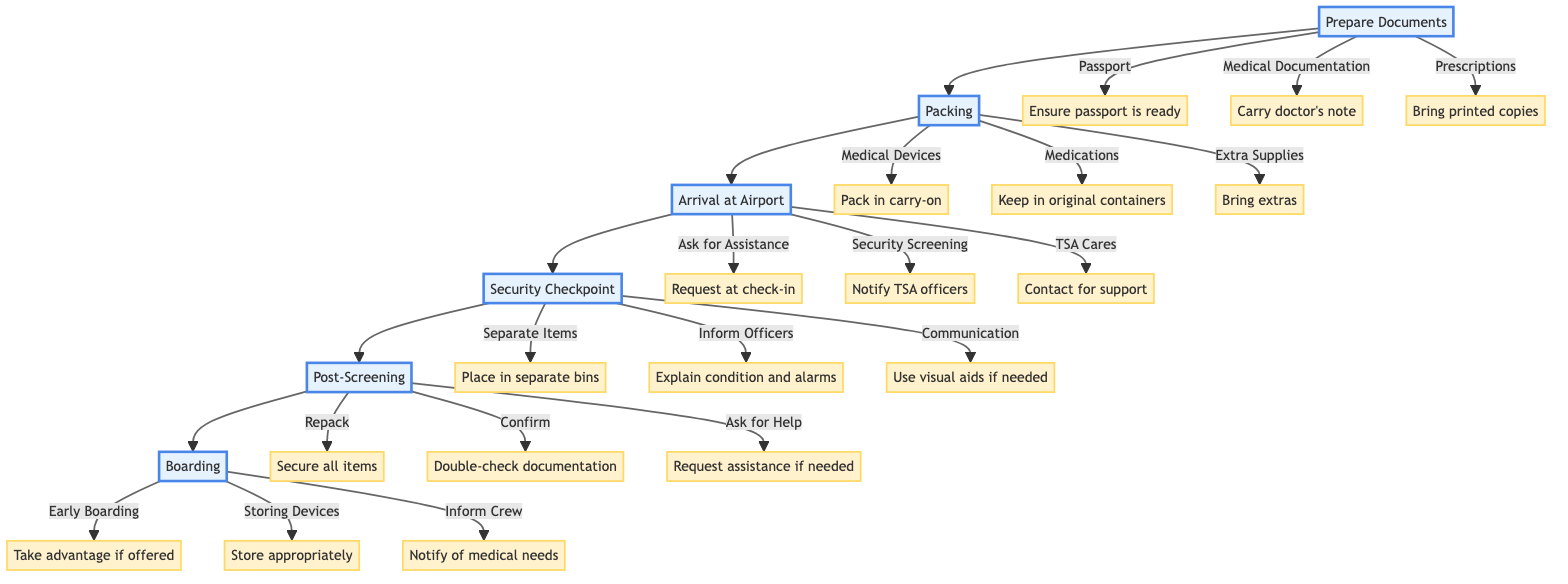What is the first step in the diagram? The diagram starts with the first step labeled "Prepare Documents". Therefore, the first step refers to gathering necessary documents prior to arriving at the airport.
Answer: Prepare Documents How many steps are there in the entire process? By counting the distinct steps, there are a total of six steps outlined in the diagram. These steps are: Prepare Documents, Packing, Arrival at Airport, Security Checkpoint, Post-Screening, and Boarding.
Answer: 6 What is included in the "Packing" step? The "Packing" step includes three key details: Pack medical devices in your carry-on bag, Keep medications in their original, labeled containers, and Bring extra batteries and supplies for your medical devices.
Answer: Medical Devices, Medications, Extra Supplies Which step comes after "Security Checkpoint"? The step that follows "Security Checkpoint" is "Post-Screening". This means after completing the security check, the next part of the process is to repack and confirm the medical items.
Answer: Post-Screening What should you do upon arrival at the airport if you need assistance? If assistance is needed when you arrive at the airport, you should request help at the check-in counter. This indicates the importance of seeking support for easier navigation through the airport.
Answer: Ask for Assistance What are two key actions to take during the "Security Checkpoint"? During the "Security Checkpoint," two important actions are to place medical devices and medications in separate bins and to clearly explain your medical condition and any device alarms to TSA officers. These actions ensure proper handling during security screening.
Answer: Separate Medical Items, Inform TSA Officers What is a suggested practice for boarding? One suggested practice for boarding is to take advantage of early boarding options. This allows individuals to have more time to settle in after boarding the aircraft.
Answer: Early Boarding How should medical devices be stored during the flight? Medical devices should be stored appropriately, either under the seat or in the overhead bins, depending on the specific needs and situation during the flight.
Answer: Store devices under the seat or in overhead bins What should you check after security screening? After security screening, it is important to double-check that you have all your medical documentation. This ensures that nothing is overlooked, and all necessary documents are in your possession.
Answer: Confirm Items 